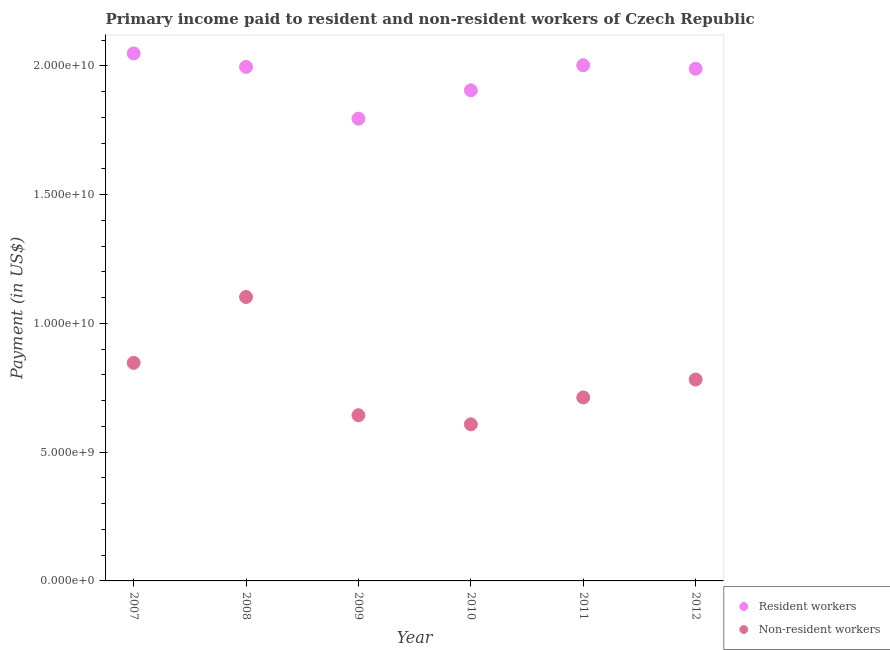Is the number of dotlines equal to the number of legend labels?
Your answer should be compact. Yes. What is the payment made to resident workers in 2008?
Ensure brevity in your answer.  2.00e+1. Across all years, what is the maximum payment made to non-resident workers?
Ensure brevity in your answer.  1.10e+1. Across all years, what is the minimum payment made to resident workers?
Ensure brevity in your answer.  1.80e+1. In which year was the payment made to resident workers maximum?
Your answer should be compact. 2007. What is the total payment made to resident workers in the graph?
Your answer should be very brief. 1.17e+11. What is the difference between the payment made to resident workers in 2008 and that in 2011?
Offer a very short reply. -6.59e+07. What is the difference between the payment made to resident workers in 2011 and the payment made to non-resident workers in 2010?
Offer a terse response. 1.39e+1. What is the average payment made to resident workers per year?
Give a very brief answer. 1.96e+1. In the year 2011, what is the difference between the payment made to resident workers and payment made to non-resident workers?
Provide a succinct answer. 1.29e+1. In how many years, is the payment made to non-resident workers greater than 4000000000 US$?
Ensure brevity in your answer.  6. What is the ratio of the payment made to resident workers in 2007 to that in 2009?
Ensure brevity in your answer.  1.14. Is the difference between the payment made to resident workers in 2008 and 2011 greater than the difference between the payment made to non-resident workers in 2008 and 2011?
Offer a very short reply. No. What is the difference between the highest and the second highest payment made to resident workers?
Your answer should be very brief. 4.58e+08. What is the difference between the highest and the lowest payment made to non-resident workers?
Ensure brevity in your answer.  4.95e+09. In how many years, is the payment made to non-resident workers greater than the average payment made to non-resident workers taken over all years?
Your response must be concise. 2. Is the payment made to resident workers strictly less than the payment made to non-resident workers over the years?
Your answer should be compact. No. How many dotlines are there?
Offer a very short reply. 2. How many years are there in the graph?
Your response must be concise. 6. What is the difference between two consecutive major ticks on the Y-axis?
Your response must be concise. 5.00e+09. Does the graph contain grids?
Give a very brief answer. No. Where does the legend appear in the graph?
Provide a short and direct response. Bottom right. How many legend labels are there?
Keep it short and to the point. 2. What is the title of the graph?
Offer a very short reply. Primary income paid to resident and non-resident workers of Czech Republic. Does "Import" appear as one of the legend labels in the graph?
Provide a short and direct response. No. What is the label or title of the X-axis?
Your response must be concise. Year. What is the label or title of the Y-axis?
Provide a short and direct response. Payment (in US$). What is the Payment (in US$) of Resident workers in 2007?
Keep it short and to the point. 2.05e+1. What is the Payment (in US$) in Non-resident workers in 2007?
Your answer should be compact. 8.47e+09. What is the Payment (in US$) of Resident workers in 2008?
Provide a succinct answer. 2.00e+1. What is the Payment (in US$) in Non-resident workers in 2008?
Ensure brevity in your answer.  1.10e+1. What is the Payment (in US$) of Resident workers in 2009?
Offer a very short reply. 1.80e+1. What is the Payment (in US$) of Non-resident workers in 2009?
Your response must be concise. 6.44e+09. What is the Payment (in US$) of Resident workers in 2010?
Offer a terse response. 1.91e+1. What is the Payment (in US$) in Non-resident workers in 2010?
Your answer should be very brief. 6.08e+09. What is the Payment (in US$) of Resident workers in 2011?
Provide a succinct answer. 2.00e+1. What is the Payment (in US$) in Non-resident workers in 2011?
Make the answer very short. 7.13e+09. What is the Payment (in US$) of Resident workers in 2012?
Provide a short and direct response. 1.99e+1. What is the Payment (in US$) in Non-resident workers in 2012?
Provide a short and direct response. 7.82e+09. Across all years, what is the maximum Payment (in US$) of Resident workers?
Ensure brevity in your answer.  2.05e+1. Across all years, what is the maximum Payment (in US$) in Non-resident workers?
Offer a very short reply. 1.10e+1. Across all years, what is the minimum Payment (in US$) of Resident workers?
Give a very brief answer. 1.80e+1. Across all years, what is the minimum Payment (in US$) of Non-resident workers?
Provide a short and direct response. 6.08e+09. What is the total Payment (in US$) of Resident workers in the graph?
Your answer should be very brief. 1.17e+11. What is the total Payment (in US$) in Non-resident workers in the graph?
Provide a succinct answer. 4.70e+1. What is the difference between the Payment (in US$) of Resident workers in 2007 and that in 2008?
Keep it short and to the point. 5.24e+08. What is the difference between the Payment (in US$) in Non-resident workers in 2007 and that in 2008?
Your answer should be very brief. -2.56e+09. What is the difference between the Payment (in US$) of Resident workers in 2007 and that in 2009?
Your response must be concise. 2.53e+09. What is the difference between the Payment (in US$) in Non-resident workers in 2007 and that in 2009?
Your answer should be very brief. 2.03e+09. What is the difference between the Payment (in US$) of Resident workers in 2007 and that in 2010?
Ensure brevity in your answer.  1.43e+09. What is the difference between the Payment (in US$) of Non-resident workers in 2007 and that in 2010?
Provide a succinct answer. 2.39e+09. What is the difference between the Payment (in US$) of Resident workers in 2007 and that in 2011?
Provide a succinct answer. 4.58e+08. What is the difference between the Payment (in US$) of Non-resident workers in 2007 and that in 2011?
Give a very brief answer. 1.34e+09. What is the difference between the Payment (in US$) in Resident workers in 2007 and that in 2012?
Keep it short and to the point. 5.95e+08. What is the difference between the Payment (in US$) of Non-resident workers in 2007 and that in 2012?
Provide a succinct answer. 6.47e+08. What is the difference between the Payment (in US$) in Resident workers in 2008 and that in 2009?
Offer a very short reply. 2.01e+09. What is the difference between the Payment (in US$) in Non-resident workers in 2008 and that in 2009?
Ensure brevity in your answer.  4.59e+09. What is the difference between the Payment (in US$) in Resident workers in 2008 and that in 2010?
Your response must be concise. 9.10e+08. What is the difference between the Payment (in US$) of Non-resident workers in 2008 and that in 2010?
Provide a short and direct response. 4.95e+09. What is the difference between the Payment (in US$) of Resident workers in 2008 and that in 2011?
Provide a short and direct response. -6.59e+07. What is the difference between the Payment (in US$) in Non-resident workers in 2008 and that in 2011?
Keep it short and to the point. 3.90e+09. What is the difference between the Payment (in US$) in Resident workers in 2008 and that in 2012?
Offer a very short reply. 7.18e+07. What is the difference between the Payment (in US$) of Non-resident workers in 2008 and that in 2012?
Give a very brief answer. 3.21e+09. What is the difference between the Payment (in US$) in Resident workers in 2009 and that in 2010?
Your answer should be compact. -1.10e+09. What is the difference between the Payment (in US$) of Non-resident workers in 2009 and that in 2010?
Provide a short and direct response. 3.54e+08. What is the difference between the Payment (in US$) of Resident workers in 2009 and that in 2011?
Offer a terse response. -2.08e+09. What is the difference between the Payment (in US$) in Non-resident workers in 2009 and that in 2011?
Provide a short and direct response. -6.90e+08. What is the difference between the Payment (in US$) of Resident workers in 2009 and that in 2012?
Offer a very short reply. -1.94e+09. What is the difference between the Payment (in US$) of Non-resident workers in 2009 and that in 2012?
Provide a short and direct response. -1.39e+09. What is the difference between the Payment (in US$) in Resident workers in 2010 and that in 2011?
Make the answer very short. -9.76e+08. What is the difference between the Payment (in US$) of Non-resident workers in 2010 and that in 2011?
Your response must be concise. -1.04e+09. What is the difference between the Payment (in US$) of Resident workers in 2010 and that in 2012?
Provide a short and direct response. -8.38e+08. What is the difference between the Payment (in US$) of Non-resident workers in 2010 and that in 2012?
Offer a very short reply. -1.74e+09. What is the difference between the Payment (in US$) in Resident workers in 2011 and that in 2012?
Make the answer very short. 1.38e+08. What is the difference between the Payment (in US$) in Non-resident workers in 2011 and that in 2012?
Your response must be concise. -6.96e+08. What is the difference between the Payment (in US$) in Resident workers in 2007 and the Payment (in US$) in Non-resident workers in 2008?
Offer a terse response. 9.46e+09. What is the difference between the Payment (in US$) in Resident workers in 2007 and the Payment (in US$) in Non-resident workers in 2009?
Make the answer very short. 1.41e+1. What is the difference between the Payment (in US$) of Resident workers in 2007 and the Payment (in US$) of Non-resident workers in 2010?
Provide a succinct answer. 1.44e+1. What is the difference between the Payment (in US$) in Resident workers in 2007 and the Payment (in US$) in Non-resident workers in 2011?
Give a very brief answer. 1.34e+1. What is the difference between the Payment (in US$) in Resident workers in 2007 and the Payment (in US$) in Non-resident workers in 2012?
Provide a short and direct response. 1.27e+1. What is the difference between the Payment (in US$) of Resident workers in 2008 and the Payment (in US$) of Non-resident workers in 2009?
Provide a short and direct response. 1.35e+1. What is the difference between the Payment (in US$) of Resident workers in 2008 and the Payment (in US$) of Non-resident workers in 2010?
Ensure brevity in your answer.  1.39e+1. What is the difference between the Payment (in US$) of Resident workers in 2008 and the Payment (in US$) of Non-resident workers in 2011?
Offer a terse response. 1.28e+1. What is the difference between the Payment (in US$) of Resident workers in 2008 and the Payment (in US$) of Non-resident workers in 2012?
Your answer should be very brief. 1.21e+1. What is the difference between the Payment (in US$) in Resident workers in 2009 and the Payment (in US$) in Non-resident workers in 2010?
Offer a terse response. 1.19e+1. What is the difference between the Payment (in US$) in Resident workers in 2009 and the Payment (in US$) in Non-resident workers in 2011?
Provide a succinct answer. 1.08e+1. What is the difference between the Payment (in US$) in Resident workers in 2009 and the Payment (in US$) in Non-resident workers in 2012?
Offer a terse response. 1.01e+1. What is the difference between the Payment (in US$) of Resident workers in 2010 and the Payment (in US$) of Non-resident workers in 2011?
Your answer should be very brief. 1.19e+1. What is the difference between the Payment (in US$) of Resident workers in 2010 and the Payment (in US$) of Non-resident workers in 2012?
Make the answer very short. 1.12e+1. What is the difference between the Payment (in US$) in Resident workers in 2011 and the Payment (in US$) in Non-resident workers in 2012?
Provide a short and direct response. 1.22e+1. What is the average Payment (in US$) in Resident workers per year?
Keep it short and to the point. 1.96e+1. What is the average Payment (in US$) of Non-resident workers per year?
Offer a terse response. 7.83e+09. In the year 2007, what is the difference between the Payment (in US$) in Resident workers and Payment (in US$) in Non-resident workers?
Your answer should be very brief. 1.20e+1. In the year 2008, what is the difference between the Payment (in US$) of Resident workers and Payment (in US$) of Non-resident workers?
Keep it short and to the point. 8.94e+09. In the year 2009, what is the difference between the Payment (in US$) in Resident workers and Payment (in US$) in Non-resident workers?
Give a very brief answer. 1.15e+1. In the year 2010, what is the difference between the Payment (in US$) in Resident workers and Payment (in US$) in Non-resident workers?
Ensure brevity in your answer.  1.30e+1. In the year 2011, what is the difference between the Payment (in US$) in Resident workers and Payment (in US$) in Non-resident workers?
Make the answer very short. 1.29e+1. In the year 2012, what is the difference between the Payment (in US$) in Resident workers and Payment (in US$) in Non-resident workers?
Offer a terse response. 1.21e+1. What is the ratio of the Payment (in US$) of Resident workers in 2007 to that in 2008?
Offer a very short reply. 1.03. What is the ratio of the Payment (in US$) of Non-resident workers in 2007 to that in 2008?
Keep it short and to the point. 0.77. What is the ratio of the Payment (in US$) in Resident workers in 2007 to that in 2009?
Make the answer very short. 1.14. What is the ratio of the Payment (in US$) in Non-resident workers in 2007 to that in 2009?
Offer a terse response. 1.32. What is the ratio of the Payment (in US$) of Resident workers in 2007 to that in 2010?
Provide a succinct answer. 1.08. What is the ratio of the Payment (in US$) in Non-resident workers in 2007 to that in 2010?
Your answer should be very brief. 1.39. What is the ratio of the Payment (in US$) of Resident workers in 2007 to that in 2011?
Keep it short and to the point. 1.02. What is the ratio of the Payment (in US$) in Non-resident workers in 2007 to that in 2011?
Your answer should be very brief. 1.19. What is the ratio of the Payment (in US$) in Resident workers in 2007 to that in 2012?
Give a very brief answer. 1.03. What is the ratio of the Payment (in US$) in Non-resident workers in 2007 to that in 2012?
Make the answer very short. 1.08. What is the ratio of the Payment (in US$) in Resident workers in 2008 to that in 2009?
Offer a terse response. 1.11. What is the ratio of the Payment (in US$) of Non-resident workers in 2008 to that in 2009?
Offer a very short reply. 1.71. What is the ratio of the Payment (in US$) of Resident workers in 2008 to that in 2010?
Make the answer very short. 1.05. What is the ratio of the Payment (in US$) in Non-resident workers in 2008 to that in 2010?
Provide a short and direct response. 1.81. What is the ratio of the Payment (in US$) of Resident workers in 2008 to that in 2011?
Your response must be concise. 1. What is the ratio of the Payment (in US$) in Non-resident workers in 2008 to that in 2011?
Ensure brevity in your answer.  1.55. What is the ratio of the Payment (in US$) of Non-resident workers in 2008 to that in 2012?
Ensure brevity in your answer.  1.41. What is the ratio of the Payment (in US$) of Resident workers in 2009 to that in 2010?
Offer a terse response. 0.94. What is the ratio of the Payment (in US$) of Non-resident workers in 2009 to that in 2010?
Provide a succinct answer. 1.06. What is the ratio of the Payment (in US$) of Resident workers in 2009 to that in 2011?
Provide a succinct answer. 0.9. What is the ratio of the Payment (in US$) of Non-resident workers in 2009 to that in 2011?
Offer a terse response. 0.9. What is the ratio of the Payment (in US$) in Resident workers in 2009 to that in 2012?
Your answer should be compact. 0.9. What is the ratio of the Payment (in US$) in Non-resident workers in 2009 to that in 2012?
Your response must be concise. 0.82. What is the ratio of the Payment (in US$) in Resident workers in 2010 to that in 2011?
Keep it short and to the point. 0.95. What is the ratio of the Payment (in US$) of Non-resident workers in 2010 to that in 2011?
Provide a short and direct response. 0.85. What is the ratio of the Payment (in US$) of Resident workers in 2010 to that in 2012?
Your response must be concise. 0.96. What is the ratio of the Payment (in US$) in Non-resident workers in 2010 to that in 2012?
Your response must be concise. 0.78. What is the ratio of the Payment (in US$) in Non-resident workers in 2011 to that in 2012?
Ensure brevity in your answer.  0.91. What is the difference between the highest and the second highest Payment (in US$) of Resident workers?
Offer a very short reply. 4.58e+08. What is the difference between the highest and the second highest Payment (in US$) of Non-resident workers?
Ensure brevity in your answer.  2.56e+09. What is the difference between the highest and the lowest Payment (in US$) of Resident workers?
Your answer should be compact. 2.53e+09. What is the difference between the highest and the lowest Payment (in US$) in Non-resident workers?
Give a very brief answer. 4.95e+09. 